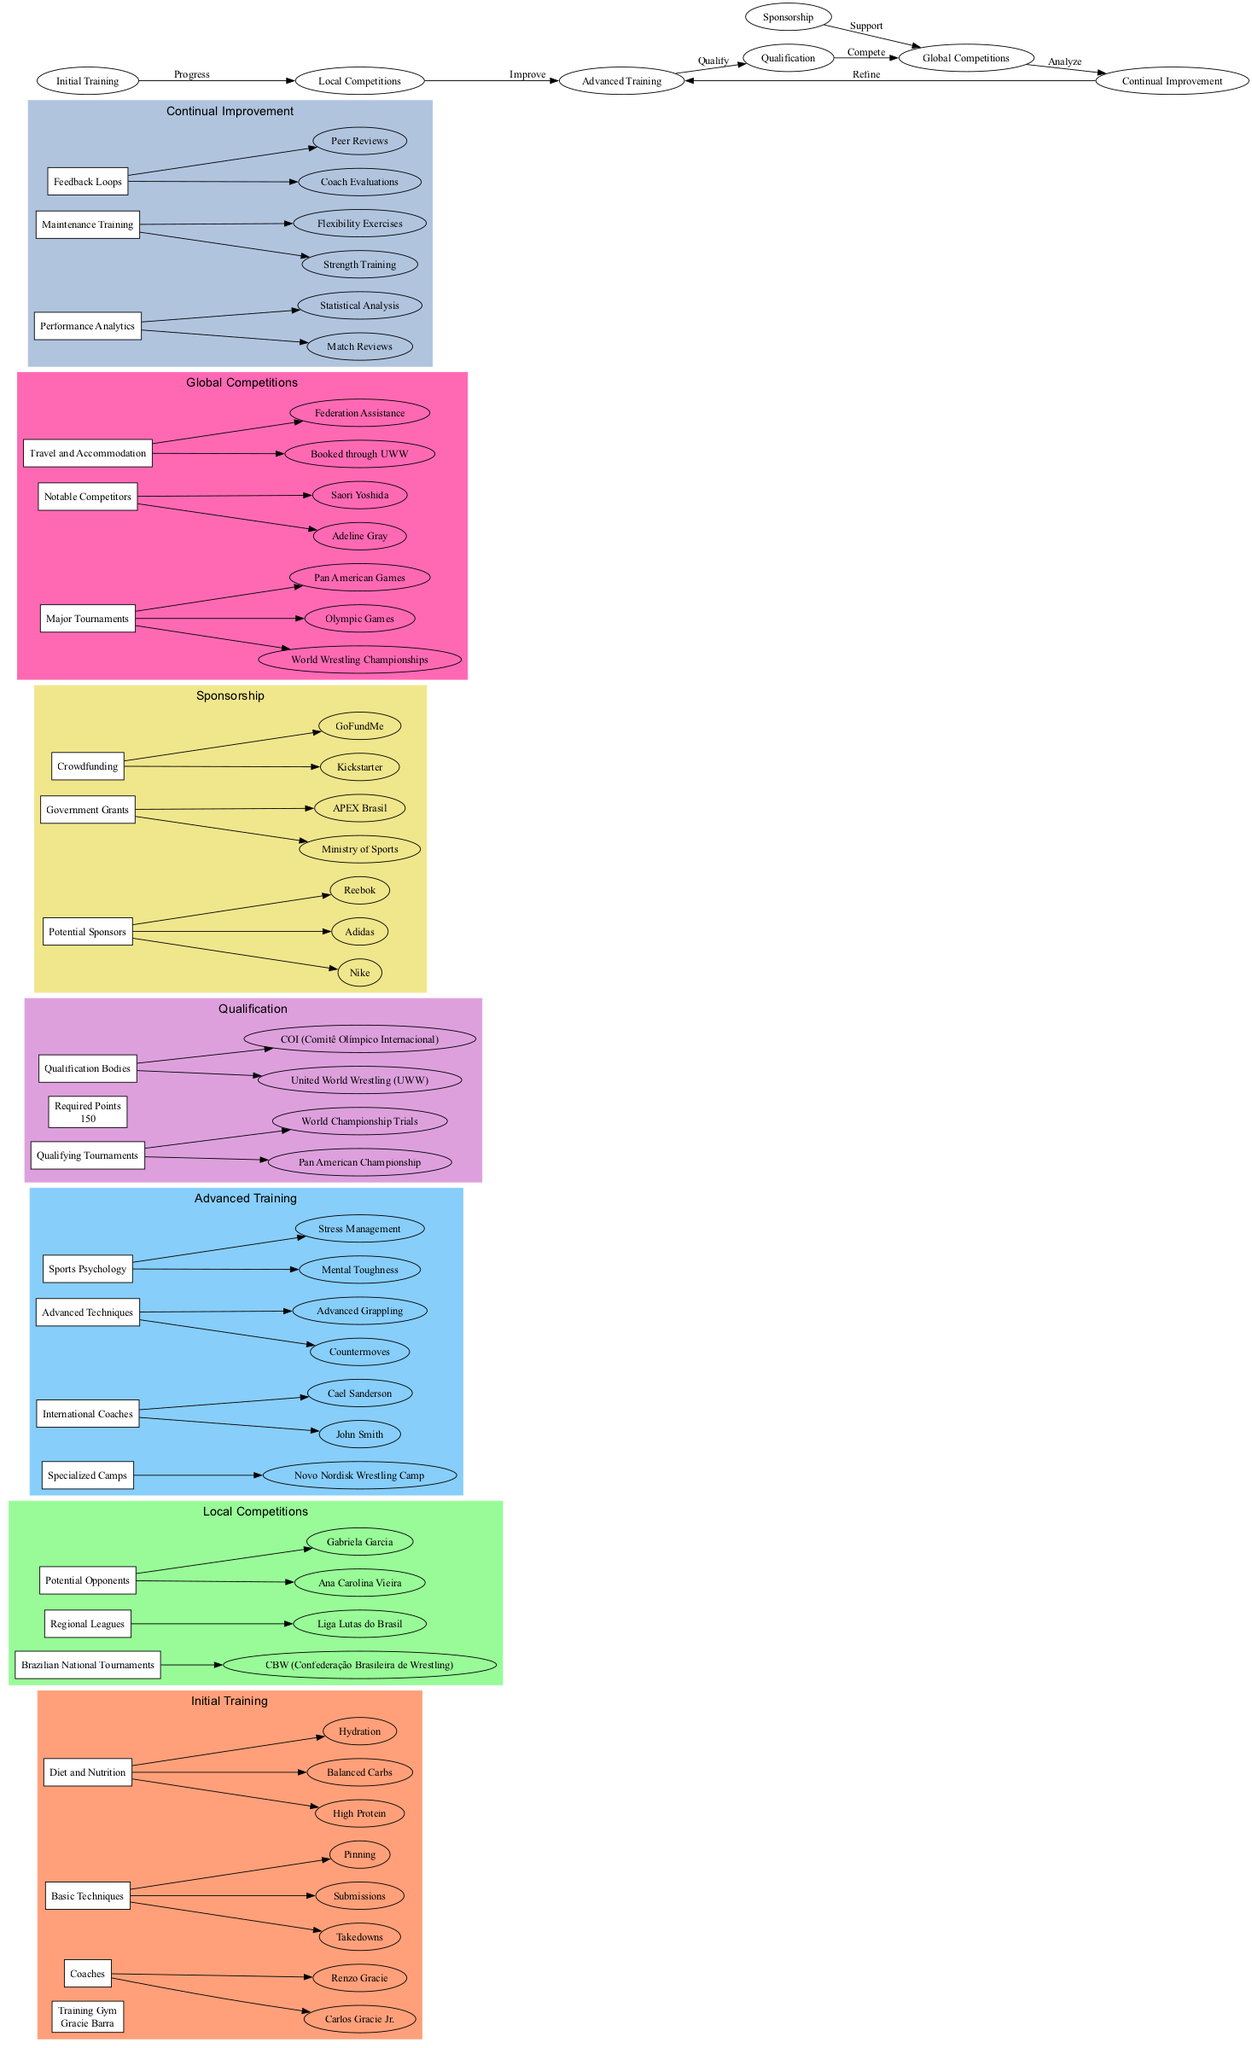What is the training gym mentioned under Initial Training? The diagram shows "Gracie Barra" listed as the Training Gym under the Initial Training category.
Answer: Gracie Barra How many potential opponents are listed under Local Competitions? There are two potential opponents named "Ana Carolina Vieira" and "Gabriela Garcia" under Local Competitions, thus the count is 2.
Answer: 2 What are the two major tournaments listed under Global Competitions? The diagram contains "World Wrestling Championships" and "Olympic Games" as the major tournaments under Global Competitions.
Answer: World Wrestling Championships, Olympic Games What is the required points for qualification in tournaments? In the Qualification section, it states that the required points for competing in qualifying tournaments is 150.
Answer: 150 Which two sponsors are mentioned in the Sponsorship category? The diagram lists "Nike" and "Adidas" as potential sponsors under the Sponsorship category.
Answer: Nike, Adidas After competing in Global Competitions, what is the next step outlined? According to the flow in the diagram, after Global Competitions, the next step is to "Analyze," which is part of the Continual Improvement process.
Answer: Analyze What type of training is involved in the Advanced Training section? The Advanced Training section includes "Specialized Camps" and "International Coaches," indicating the type of training that athletes undergo at this stage.
Answer: Specialized Camps, International Coaches What connects Local Competitions to Advanced Training? The diagram shows an edge marked "Improve" that links Local Competitions to Advanced Training, indicating the relationship where local competition experiences lead to improved training.
Answer: Improve How is support provided for Global Competitions? The Sponsorship section indicates that support for Global Competitions is received through "Government Grants" and "Potential Sponsors," emphasizing the avenues of support available.
Answer: Government Grants, Potential Sponsors 